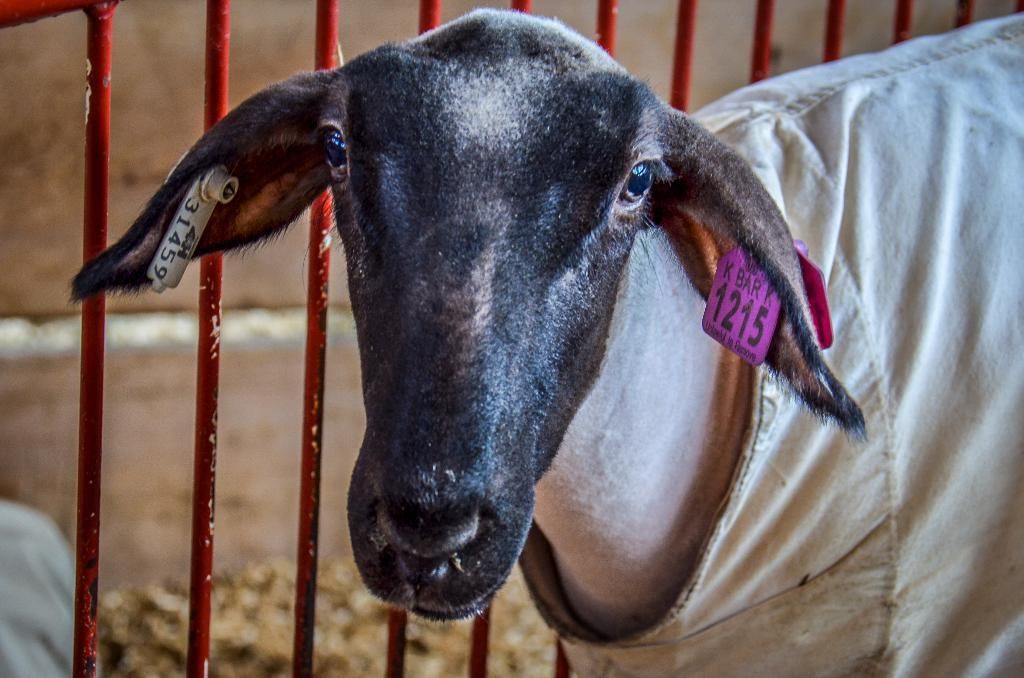What type of animal is in the image? There is an animal in the image, but the specific type cannot be determined from the provided facts. What is covering the animal in the image? The animal has a cloth on it. How is the animal identified in the image? The animal has a number tag. Where is the animal located in relation to the fence? The animal is near a fence. What is the condition of the background in the image? The background of the image is blurred. What type of bell can be heard ringing in the image? There is no bell present in the image, and therefore no sound can be heard. What event is taking place in the image related to the birth of a new animal? There is no indication of a birth event in the image; the animal has a number tag, which suggests it may be part of a group or identification system. 